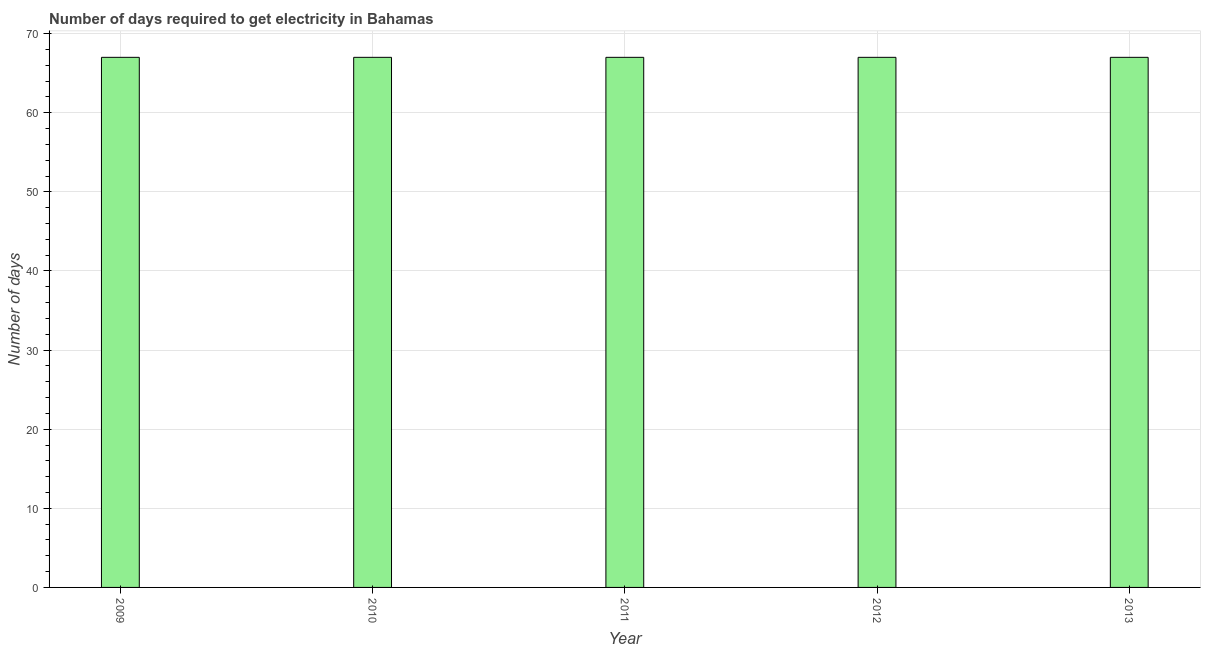Does the graph contain any zero values?
Provide a short and direct response. No. Does the graph contain grids?
Provide a short and direct response. Yes. What is the title of the graph?
Ensure brevity in your answer.  Number of days required to get electricity in Bahamas. What is the label or title of the X-axis?
Offer a very short reply. Year. What is the label or title of the Y-axis?
Your response must be concise. Number of days. What is the time to get electricity in 2012?
Offer a very short reply. 67. Across all years, what is the maximum time to get electricity?
Your answer should be very brief. 67. Across all years, what is the minimum time to get electricity?
Offer a very short reply. 67. In which year was the time to get electricity minimum?
Ensure brevity in your answer.  2009. What is the sum of the time to get electricity?
Offer a very short reply. 335. What is the difference between the time to get electricity in 2011 and 2013?
Give a very brief answer. 0. What is the average time to get electricity per year?
Your answer should be very brief. 67. What is the median time to get electricity?
Provide a succinct answer. 67. Is the time to get electricity in 2011 less than that in 2013?
Your response must be concise. No. Is the difference between the time to get electricity in 2009 and 2011 greater than the difference between any two years?
Keep it short and to the point. Yes. Is the sum of the time to get electricity in 2011 and 2013 greater than the maximum time to get electricity across all years?
Give a very brief answer. Yes. In how many years, is the time to get electricity greater than the average time to get electricity taken over all years?
Offer a very short reply. 0. How many bars are there?
Offer a very short reply. 5. How many years are there in the graph?
Provide a short and direct response. 5. What is the difference between two consecutive major ticks on the Y-axis?
Provide a short and direct response. 10. What is the Number of days of 2009?
Offer a very short reply. 67. What is the difference between the Number of days in 2009 and 2010?
Provide a short and direct response. 0. What is the difference between the Number of days in 2009 and 2012?
Your response must be concise. 0. What is the difference between the Number of days in 2010 and 2011?
Provide a short and direct response. 0. What is the difference between the Number of days in 2010 and 2012?
Make the answer very short. 0. What is the difference between the Number of days in 2011 and 2012?
Keep it short and to the point. 0. What is the difference between the Number of days in 2012 and 2013?
Offer a terse response. 0. What is the ratio of the Number of days in 2009 to that in 2012?
Your answer should be compact. 1. What is the ratio of the Number of days in 2010 to that in 2011?
Your answer should be very brief. 1. What is the ratio of the Number of days in 2010 to that in 2012?
Your answer should be compact. 1. What is the ratio of the Number of days in 2011 to that in 2012?
Offer a terse response. 1. What is the ratio of the Number of days in 2011 to that in 2013?
Your response must be concise. 1. 